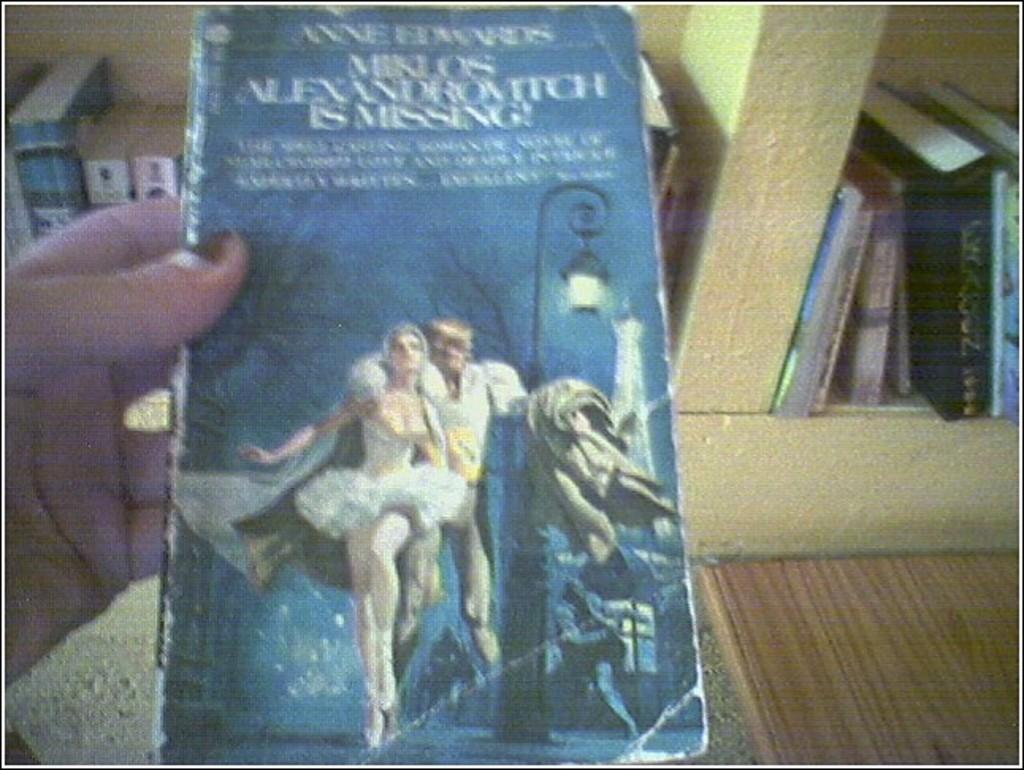Who authored the book?
Make the answer very short. Anne edwards. 